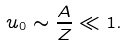Convert formula to latex. <formula><loc_0><loc_0><loc_500><loc_500>u _ { 0 } \sim \frac { A } { Z } \ll 1 .</formula> 